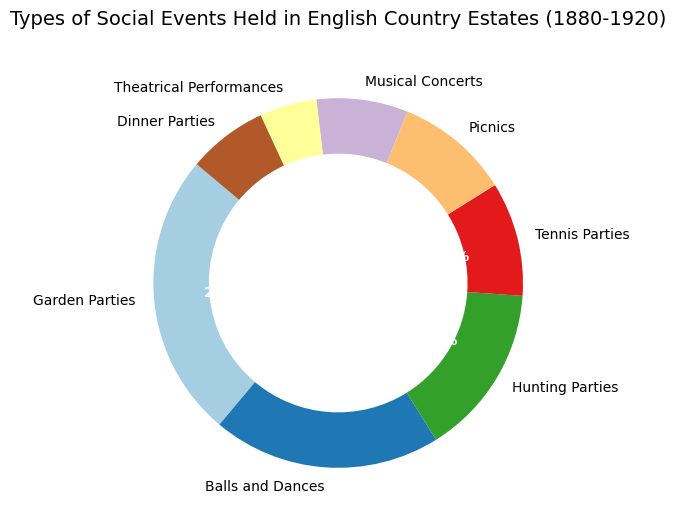Which type of social event is the most common? The pie chart displays the percentages of different types of social events. The largest segment in the chart represents Garden Parties at 25%, which is the highest percentage.
Answer: Garden Parties Which event type holds a smaller percentage: Tennis Parties or Musical Concerts? By comparing the segments, Tennis Parties represent 10%, while Musical Concerts represent 8%. Since 8% is smaller than 10%, Musical Concerts hold a smaller percentage.
Answer: Musical Concerts What is the combined percentage of Balls and Dances, and Hunting Parties? Balls and Dances account for 20% and Hunting Parties account for 15%. Adding these together, 20% + 15% = 35%.
Answer: 35% Are there more Picnics or Dinner Parties? The pie chart shows Picnics comprising 10% and Dinner Parties 7%. Comparing these values, Picnics have a greater percentage than Dinner Parties.
Answer: Picnics Identify the two event types that have equal percentages. Observing the pie chart, Tennis Parties and Picnics both have a segment size of 10%. Thus, they have equal percentages.
Answer: Tennis Parties and Picnics What percentage of events are either Theatrical Performances or Dinner Parties? Summing the percentages for Theatrical Performances (5%) and Dinner Parties (7%) gives 5% + 7% = 12%.
Answer: 12% Which segment is represented by a light blue color? Referring to the visual chart, the light blue color corresponds to the segment for Dinner Parties which accounts for 7%.
Answer: Dinner Parties How much greater is the percentage of Garden Parties compared to Musical Concerts? Garden Parties have 25% whereas Musical Concerts have 8%. The difference is calculated as 25% - 8% = 17%.
Answer: 17% What is the difference between the segments of Balls and Dances and Theatrical Performances? Balls and Dances have a percentage of 20%, while Theatrical Performances have 5%. The difference between these two values is 20% - 5% = 15%.
Answer: 15% Arrange the event types in descending order of their percentages. When we order the segments based on their percentages as shown in the pie chart: Garden Parties (25%), Balls and Dances (20%), Hunting Parties (15%), Tennis Parties (10%), Picnics (10%), Dinner Parties (7%), Musical Concerts (8%), Theatrical Performances (5%).
Answer: Garden Parties, Balls and Dances, Hunting Parties, Tennis Parties, Picnics, Musical Concerts, Dinner Parties, Theatrical Performances 